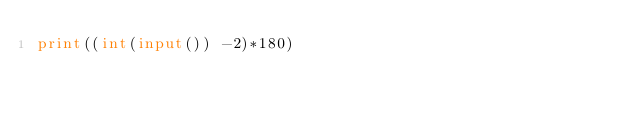<code> <loc_0><loc_0><loc_500><loc_500><_Python_>print((int(input()) -2)*180)</code> 